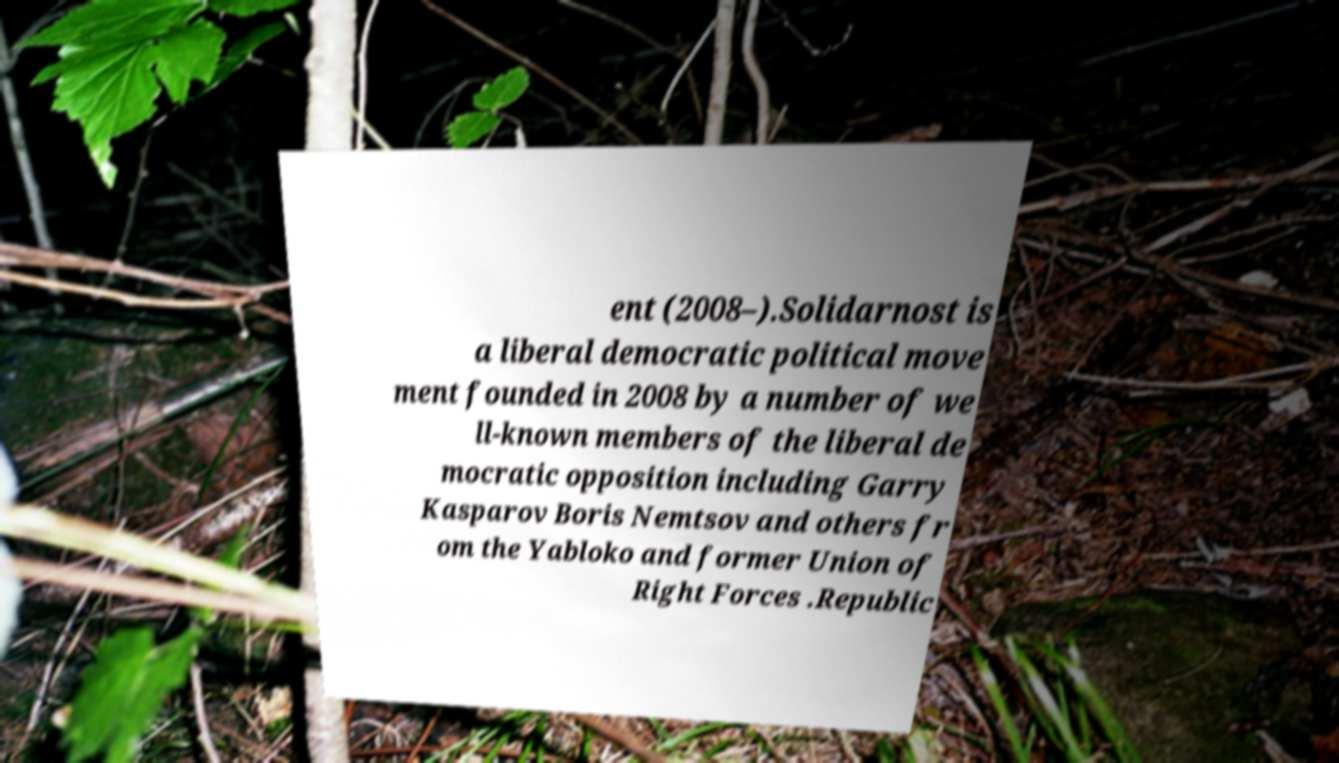There's text embedded in this image that I need extracted. Can you transcribe it verbatim? ent (2008–).Solidarnost is a liberal democratic political move ment founded in 2008 by a number of we ll-known members of the liberal de mocratic opposition including Garry Kasparov Boris Nemtsov and others fr om the Yabloko and former Union of Right Forces .Republic 